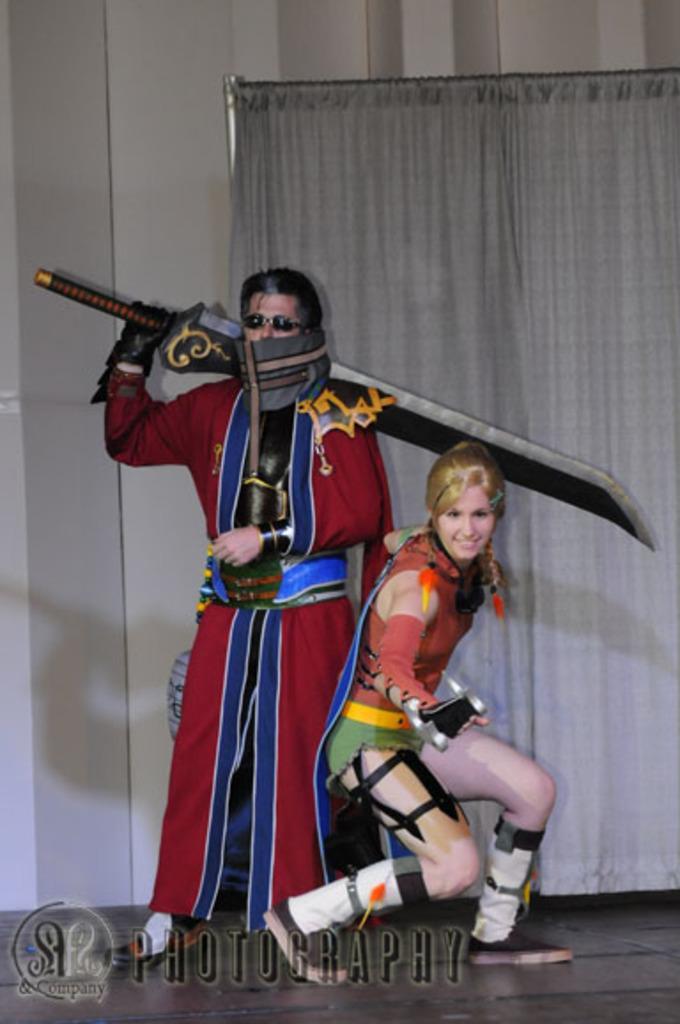Please provide a concise description of this image. In this image I can see a person wearing red and blue dress is standing and holding a knife which is black in color and a woman wearing red and green dress is standing on the ground. In the background I can see the wall and the curtain. 